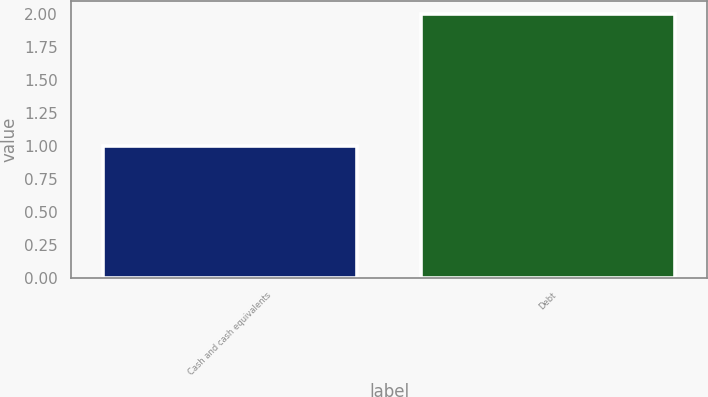Convert chart. <chart><loc_0><loc_0><loc_500><loc_500><bar_chart><fcel>Cash and cash equivalents<fcel>Debt<nl><fcel>1<fcel>2<nl></chart> 